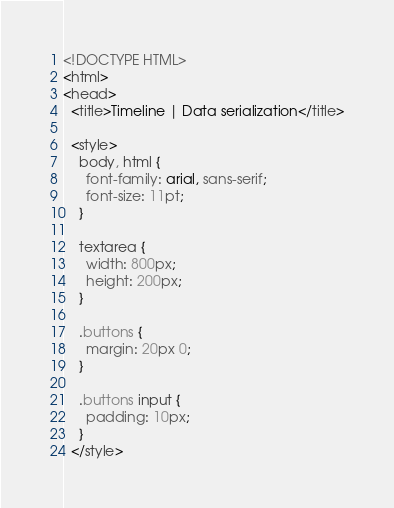Convert code to text. <code><loc_0><loc_0><loc_500><loc_500><_HTML_><!DOCTYPE HTML>
<html>
<head>
  <title>Timeline | Data serialization</title>

  <style>
    body, html {
      font-family: arial, sans-serif;
      font-size: 11pt;
    }

    textarea {
      width: 800px;
      height: 200px;
    }

    .buttons {
      margin: 20px 0;
    }

    .buttons input {
      padding: 10px;
    }
  </style>
</code> 